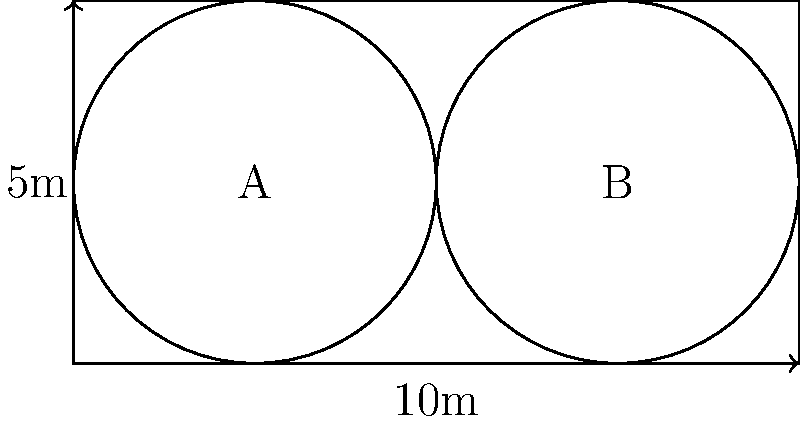As a luxury private jet designer, you're tasked with optimizing the cabin layout for maximum passenger comfort. The rectangular cabin measures 10m in length and 5m in width. Two circular seating areas, A and B, each with a radius of 2.5m, are proposed as shown in the diagram. What percentage of the cabin's total area is utilized by these circular seating areas? To solve this problem, we'll follow these steps:

1. Calculate the total area of the cabin:
   $A_{cabin} = 10m \times 5m = 50m^2$

2. Calculate the area of one circular seating area:
   $A_{circle} = \pi r^2 = \pi (2.5m)^2 = 6.25\pi m^2$

3. Calculate the total area of both circular seating areas:
   $A_{total circles} = 2 \times 6.25\pi m^2 = 12.5\pi m^2$

4. Calculate the percentage of the cabin area utilized by the circles:
   $Percentage = \frac{A_{total circles}}{A_{cabin}} \times 100\%$
   $= \frac{12.5\pi m^2}{50m^2} \times 100\%$
   $= 0.25\pi \times 100\%$
   $\approx 78.54\%$

Therefore, the circular seating areas utilize approximately 78.54% of the cabin's total area.
Answer: 78.54% 